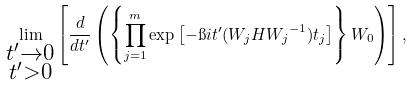<formula> <loc_0><loc_0><loc_500><loc_500>\lim _ { \substack { t ^ { \prime } \to 0 \\ t ^ { \prime } > 0 } } \left [ \frac { d } { d t ^ { \prime } } \left ( \left \{ \prod _ { j = 1 } ^ { m } \exp \left [ - \i i t ^ { \prime } ( { W } _ { j } H { { W } _ { j } } ^ { - 1 } ) t _ { j } \right ] \right \} { W } _ { 0 } \right ) \right ] ,</formula> 